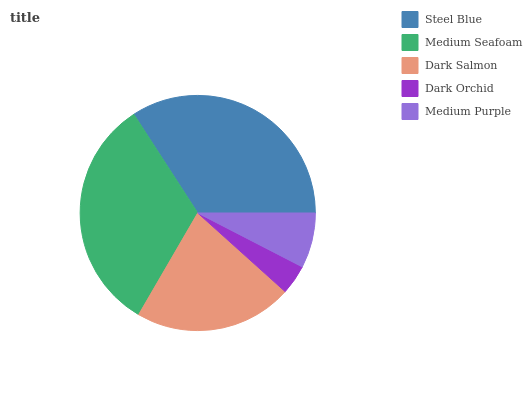Is Dark Orchid the minimum?
Answer yes or no. Yes. Is Steel Blue the maximum?
Answer yes or no. Yes. Is Medium Seafoam the minimum?
Answer yes or no. No. Is Medium Seafoam the maximum?
Answer yes or no. No. Is Steel Blue greater than Medium Seafoam?
Answer yes or no. Yes. Is Medium Seafoam less than Steel Blue?
Answer yes or no. Yes. Is Medium Seafoam greater than Steel Blue?
Answer yes or no. No. Is Steel Blue less than Medium Seafoam?
Answer yes or no. No. Is Dark Salmon the high median?
Answer yes or no. Yes. Is Dark Salmon the low median?
Answer yes or no. Yes. Is Steel Blue the high median?
Answer yes or no. No. Is Steel Blue the low median?
Answer yes or no. No. 